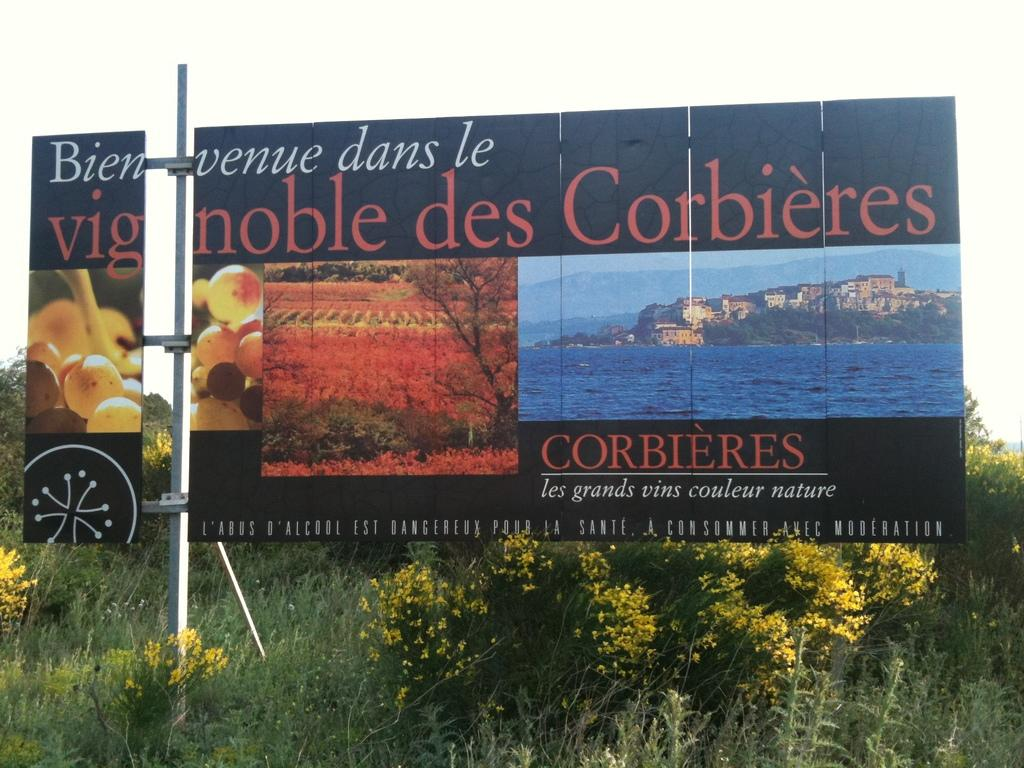What is the main object in the image that is used for advertising? The image contains a hoarding, which is used for advertising. How is the hoarding attached to its support structure? The hoarding is attached to a pole. What type of vegetation with yellow flowers can be seen in the image? There are trees with yellow flowers in the image. What other types of vegetation are present in the image? There are plants in the image. Where is the sheep located in the image? There is no sheep present in the image. What position does the stage hold in the image? There is no stage present in the image. 